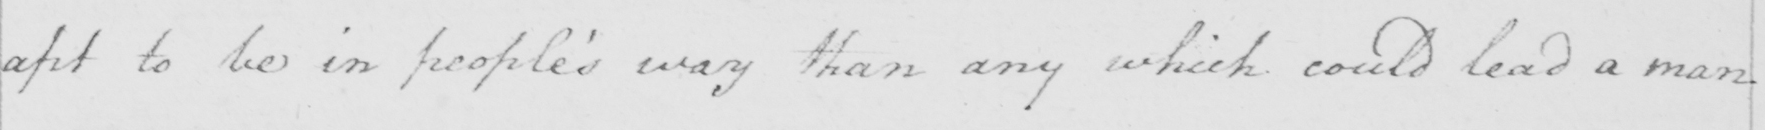Transcribe the text shown in this historical manuscript line. apt to be in people ' s way than any which could lead a man 